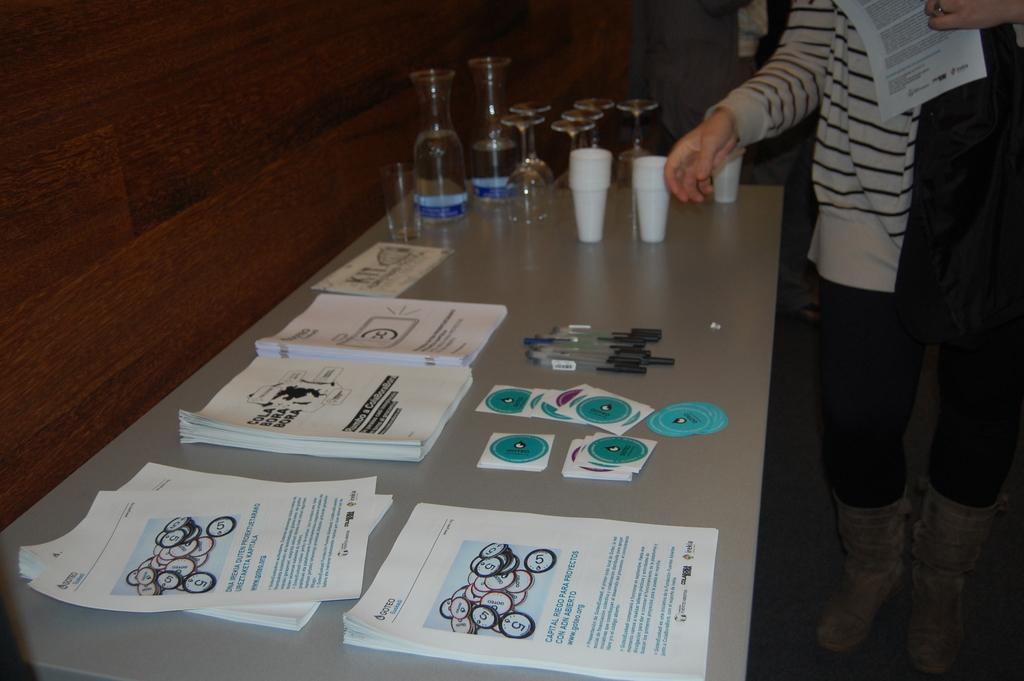What piece of furniture is in the image? There is a table in the image. What is on top of the table? Papers are bundled on the table, along with stickers, pens, and glasses. What might be used for writing in the image? Pens are present on the table. What might be used for drinking in the image? Glasses are visible on the table. Is there a person in the image? Yes, there is a person beside the table. What color of paint is being used by the person in the image? There is no paint or painting activity present in the image. 